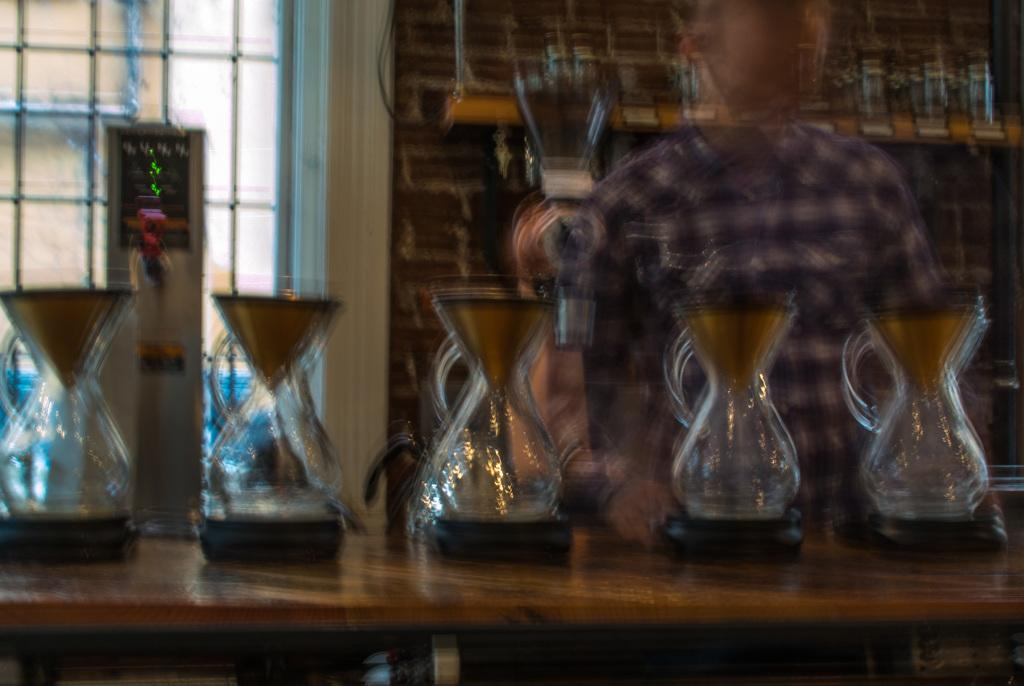What objects can be seen on the table in the foreground of the image? There are jars on a table in the foreground of the image. What can be seen in the background of the image? There is a person, a device, glasses in a rack, a wall, and a window in the background of the image. What type of soup is being prepared in the pocket of the person in the image? There is no soup or pocket visible in the image. 